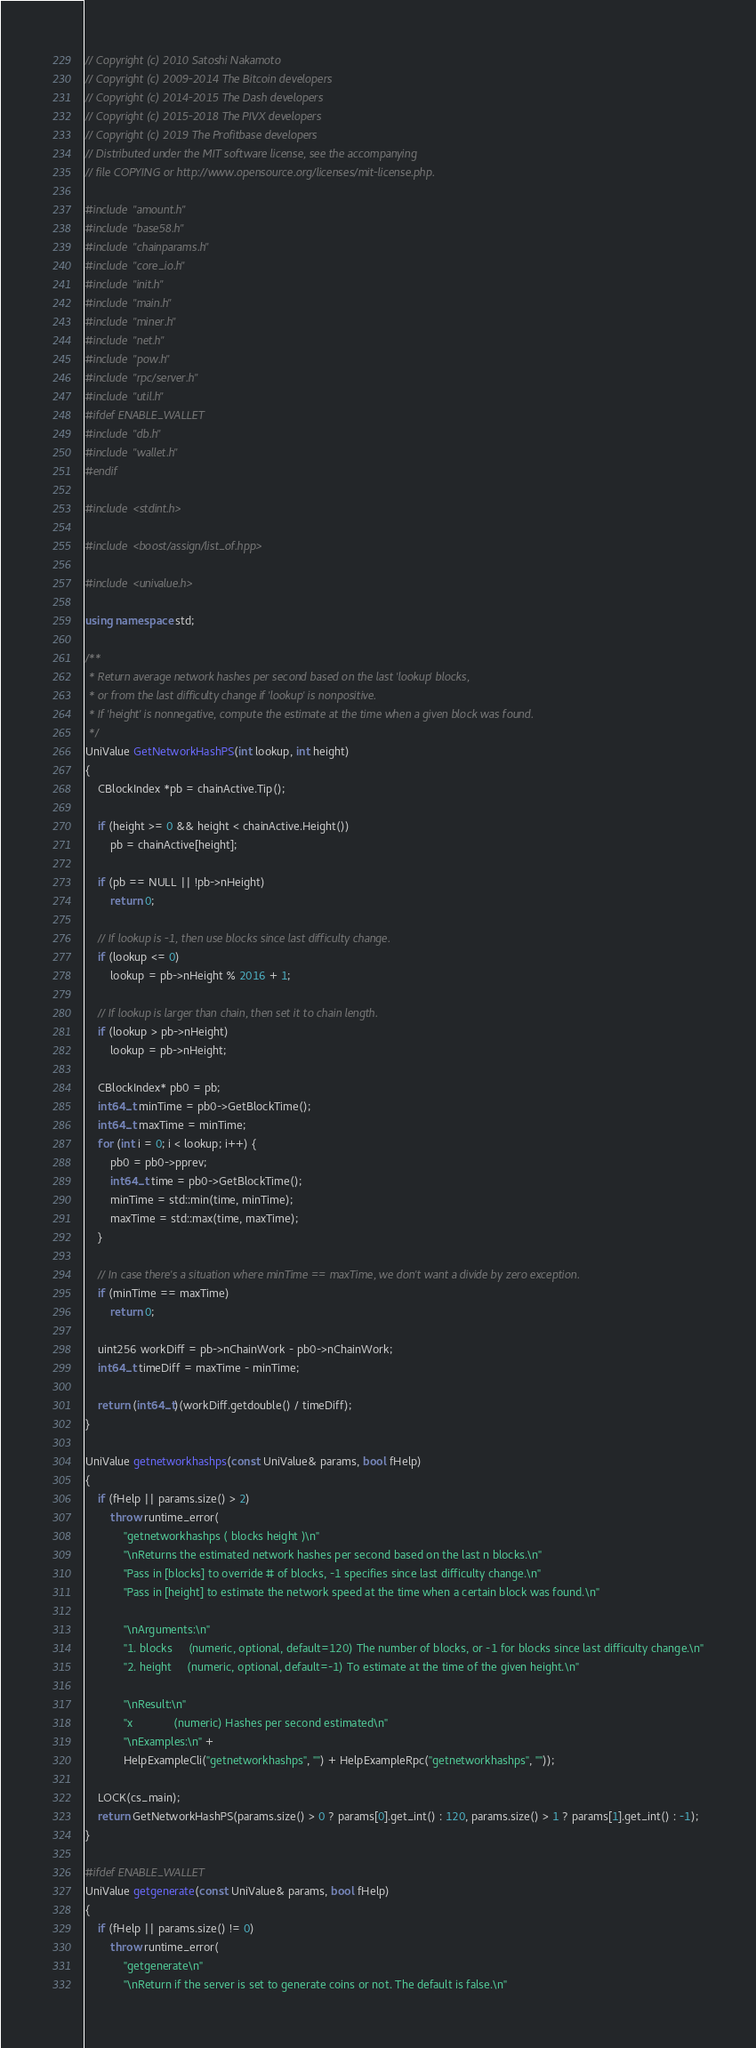Convert code to text. <code><loc_0><loc_0><loc_500><loc_500><_C++_>// Copyright (c) 2010 Satoshi Nakamoto
// Copyright (c) 2009-2014 The Bitcoin developers
// Copyright (c) 2014-2015 The Dash developers
// Copyright (c) 2015-2018 The PIVX developers
// Copyright (c) 2019 The Profitbase developers
// Distributed under the MIT software license, see the accompanying
// file COPYING or http://www.opensource.org/licenses/mit-license.php.

#include "amount.h"
#include "base58.h"
#include "chainparams.h"
#include "core_io.h"
#include "init.h"
#include "main.h"
#include "miner.h"
#include "net.h"
#include "pow.h"
#include "rpc/server.h"
#include "util.h"
#ifdef ENABLE_WALLET
#include "db.h"
#include "wallet.h"
#endif

#include <stdint.h>

#include <boost/assign/list_of.hpp>

#include <univalue.h>

using namespace std;

/**
 * Return average network hashes per second based on the last 'lookup' blocks,
 * or from the last difficulty change if 'lookup' is nonpositive.
 * If 'height' is nonnegative, compute the estimate at the time when a given block was found.
 */
UniValue GetNetworkHashPS(int lookup, int height)
{
    CBlockIndex *pb = chainActive.Tip();

    if (height >= 0 && height < chainActive.Height())
        pb = chainActive[height];

    if (pb == NULL || !pb->nHeight)
        return 0;

    // If lookup is -1, then use blocks since last difficulty change.
    if (lookup <= 0)
        lookup = pb->nHeight % 2016 + 1;

    // If lookup is larger than chain, then set it to chain length.
    if (lookup > pb->nHeight)
        lookup = pb->nHeight;

    CBlockIndex* pb0 = pb;
    int64_t minTime = pb0->GetBlockTime();
    int64_t maxTime = minTime;
    for (int i = 0; i < lookup; i++) {
        pb0 = pb0->pprev;
        int64_t time = pb0->GetBlockTime();
        minTime = std::min(time, minTime);
        maxTime = std::max(time, maxTime);
    }

    // In case there's a situation where minTime == maxTime, we don't want a divide by zero exception.
    if (minTime == maxTime)
        return 0;

    uint256 workDiff = pb->nChainWork - pb0->nChainWork;
    int64_t timeDiff = maxTime - minTime;

    return (int64_t)(workDiff.getdouble() / timeDiff);
}

UniValue getnetworkhashps(const UniValue& params, bool fHelp)
{
    if (fHelp || params.size() > 2)
        throw runtime_error(
            "getnetworkhashps ( blocks height )\n"
            "\nReturns the estimated network hashes per second based on the last n blocks.\n"
            "Pass in [blocks] to override # of blocks, -1 specifies since last difficulty change.\n"
            "Pass in [height] to estimate the network speed at the time when a certain block was found.\n"

            "\nArguments:\n"
            "1. blocks     (numeric, optional, default=120) The number of blocks, or -1 for blocks since last difficulty change.\n"
            "2. height     (numeric, optional, default=-1) To estimate at the time of the given height.\n"

            "\nResult:\n"
            "x             (numeric) Hashes per second estimated\n"
            "\nExamples:\n" +
            HelpExampleCli("getnetworkhashps", "") + HelpExampleRpc("getnetworkhashps", ""));

    LOCK(cs_main);
    return GetNetworkHashPS(params.size() > 0 ? params[0].get_int() : 120, params.size() > 1 ? params[1].get_int() : -1);
}

#ifdef ENABLE_WALLET
UniValue getgenerate(const UniValue& params, bool fHelp)
{
    if (fHelp || params.size() != 0)
        throw runtime_error(
            "getgenerate\n"
            "\nReturn if the server is set to generate coins or not. The default is false.\n"</code> 